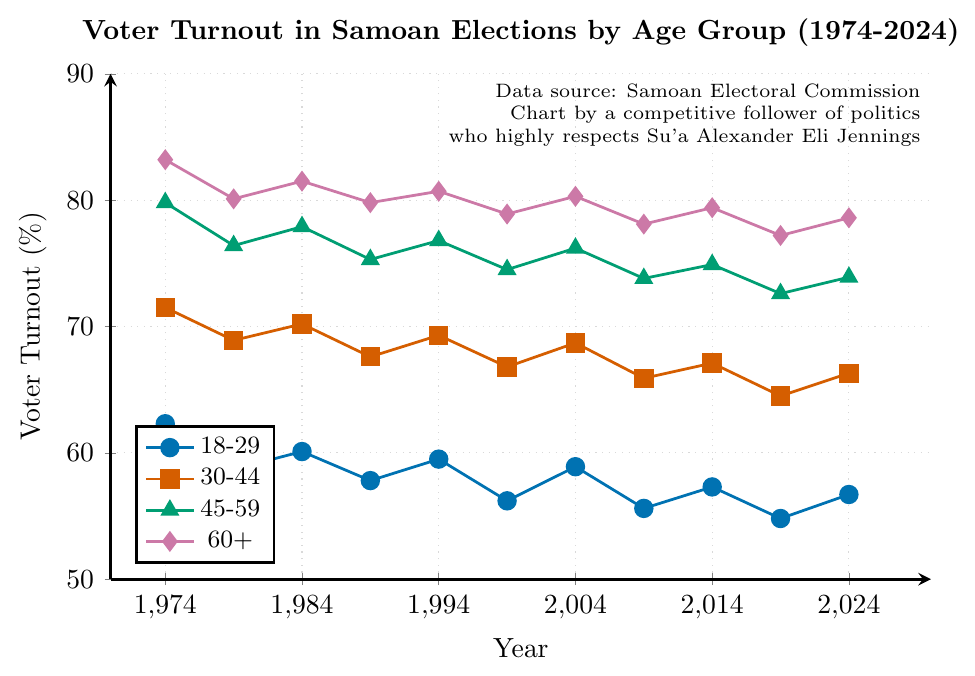What was the voter turnout for the 18-29 age group in 1974? Simply refer to the data point at the intersection of the "18-29" line and the year 1974. The value is 62.3%.
Answer: 62.3% Which age group had the highest voter turnout in 2024? Look at the data points for all age groups in the year 2024. The "60+" age group has the highest value at 78.6%.
Answer: 60+ Which year saw the lowest voter turnout for the 30-44 age group? Look across the values for the "30-44" age group. The lowest value is 64.5%, which occurs in 2019.
Answer: 2019 By how much did the voter turnout for the 45-59 age group decrease between 1974 and 2019? Subtract the turnout in 2019 (72.6%) from the turnout in 1974 (79.8%). The decrease is 79.8% - 72.6% = 7.2%.
Answer: 7.2% What is the average voter turnout for the 60+ age group over the total years displayed? Add the values for the "60+" group over each year: 83.2, 80.1, 81.5, 79.8, 80.7, 78.9, 80.3, 78.1, 79.4, 77.2, 78.6. The sum is 877.8. Divide by the number of years (11): 877.8 / 11 ≈ 79.8%.
Answer: 79.8% Which age group experienced a consistent decrease in voter turnout from 1974 to 2019? Examine all age groups to see if any trend shows a consistent decrease over the years. The "18-29" age group consistently decreased from 62.3% in 1974 to 54.8% in 2019.
Answer: 18-29 Compare the voter turnout of the 30-44 and 45-59 age groups in 1984. Which one was higher and by how much? Refer to the data points for 1984. The turnout for "30-44" is 70.2%, and for "45-59" it is 77.9%. The difference is 77.9% - 70.2% = 7.7%.
Answer: 45-59 by 7.7% What year did the 60+ age group have nearly the same voter turnout as the 45-59 age group? Compare the values for "60+" and "45-59" in the given years to find the closest. In 2014, "60+" had 79.4% and "45-59" had 74.9%, which are not very close. In other years, the differences are more significant. Thus, none of the years have nearly the same values.
Answer: None How much did the voter turnout for the 30-44 age group change from 1994 to 2004? Subtract the 1994 value (69.3%) from the 2004 value (68.7%). The change is 68.7% - 69.3% = -0.6%.
Answer: -0.6% Which age group had the least variation in voter turnout from 1974 to 2024? Calculate the range (max-min) for each age group. "18-29": 62.3-54.8=7.5%, "30-44": 71.5-64.5=7%, "45-59": 79.8-72.6=7.2%, "60+": 83.2-77.2=6%. The "60+" group had the least variation at 6%.
Answer: 60+ 